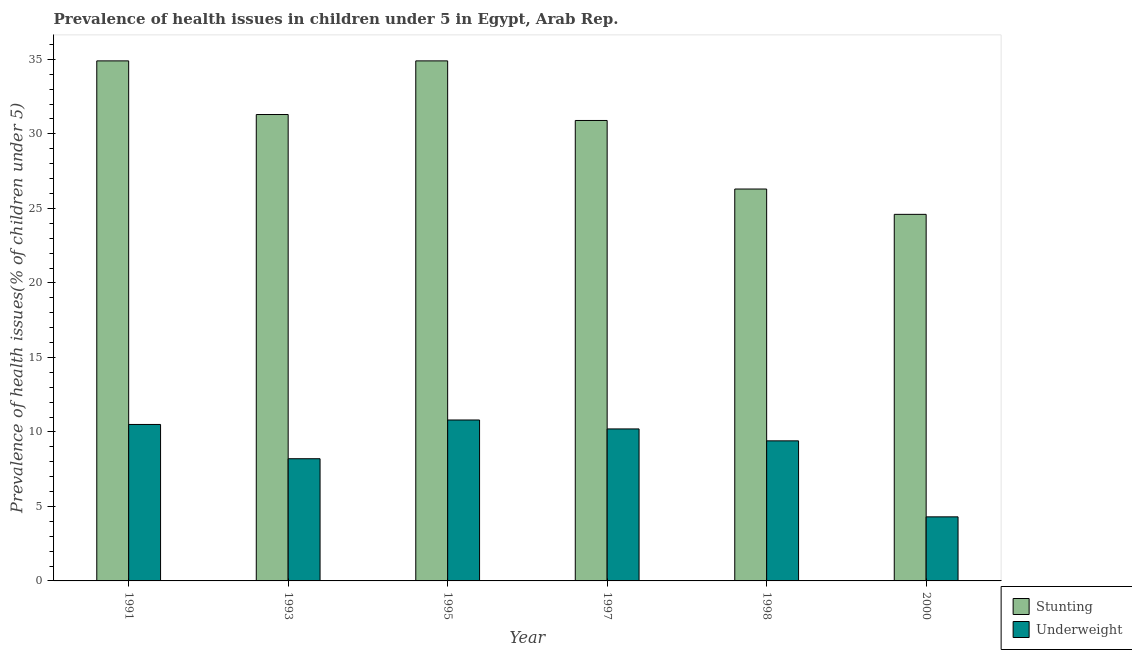How many different coloured bars are there?
Your answer should be very brief. 2. Are the number of bars on each tick of the X-axis equal?
Ensure brevity in your answer.  Yes. How many bars are there on the 6th tick from the left?
Your response must be concise. 2. What is the label of the 1st group of bars from the left?
Give a very brief answer. 1991. In how many cases, is the number of bars for a given year not equal to the number of legend labels?
Offer a terse response. 0. What is the percentage of stunted children in 2000?
Keep it short and to the point. 24.6. Across all years, what is the maximum percentage of underweight children?
Offer a very short reply. 10.8. Across all years, what is the minimum percentage of stunted children?
Keep it short and to the point. 24.6. What is the total percentage of stunted children in the graph?
Give a very brief answer. 182.9. What is the difference between the percentage of stunted children in 1993 and that in 2000?
Ensure brevity in your answer.  6.7. What is the difference between the percentage of stunted children in 1991 and the percentage of underweight children in 1993?
Your answer should be very brief. 3.6. What is the average percentage of underweight children per year?
Make the answer very short. 8.9. In the year 1993, what is the difference between the percentage of underweight children and percentage of stunted children?
Offer a terse response. 0. What is the ratio of the percentage of underweight children in 1997 to that in 1998?
Your answer should be compact. 1.09. Is the difference between the percentage of underweight children in 1991 and 1995 greater than the difference between the percentage of stunted children in 1991 and 1995?
Your response must be concise. No. What is the difference between the highest and the second highest percentage of underweight children?
Offer a terse response. 0.3. What is the difference between the highest and the lowest percentage of stunted children?
Provide a succinct answer. 10.3. Is the sum of the percentage of stunted children in 1995 and 1998 greater than the maximum percentage of underweight children across all years?
Your answer should be very brief. Yes. What does the 1st bar from the left in 1998 represents?
Make the answer very short. Stunting. What does the 2nd bar from the right in 1997 represents?
Provide a succinct answer. Stunting. How many bars are there?
Your answer should be compact. 12. How many years are there in the graph?
Provide a short and direct response. 6. How many legend labels are there?
Give a very brief answer. 2. How are the legend labels stacked?
Offer a terse response. Vertical. What is the title of the graph?
Your answer should be very brief. Prevalence of health issues in children under 5 in Egypt, Arab Rep. What is the label or title of the Y-axis?
Give a very brief answer. Prevalence of health issues(% of children under 5). What is the Prevalence of health issues(% of children under 5) of Stunting in 1991?
Offer a terse response. 34.9. What is the Prevalence of health issues(% of children under 5) of Underweight in 1991?
Keep it short and to the point. 10.5. What is the Prevalence of health issues(% of children under 5) of Stunting in 1993?
Give a very brief answer. 31.3. What is the Prevalence of health issues(% of children under 5) in Underweight in 1993?
Your answer should be compact. 8.2. What is the Prevalence of health issues(% of children under 5) of Stunting in 1995?
Provide a short and direct response. 34.9. What is the Prevalence of health issues(% of children under 5) in Underweight in 1995?
Offer a terse response. 10.8. What is the Prevalence of health issues(% of children under 5) in Stunting in 1997?
Provide a succinct answer. 30.9. What is the Prevalence of health issues(% of children under 5) of Underweight in 1997?
Keep it short and to the point. 10.2. What is the Prevalence of health issues(% of children under 5) of Stunting in 1998?
Provide a short and direct response. 26.3. What is the Prevalence of health issues(% of children under 5) of Underweight in 1998?
Your answer should be very brief. 9.4. What is the Prevalence of health issues(% of children under 5) of Stunting in 2000?
Provide a succinct answer. 24.6. What is the Prevalence of health issues(% of children under 5) of Underweight in 2000?
Your answer should be compact. 4.3. Across all years, what is the maximum Prevalence of health issues(% of children under 5) of Stunting?
Make the answer very short. 34.9. Across all years, what is the maximum Prevalence of health issues(% of children under 5) in Underweight?
Make the answer very short. 10.8. Across all years, what is the minimum Prevalence of health issues(% of children under 5) in Stunting?
Offer a very short reply. 24.6. Across all years, what is the minimum Prevalence of health issues(% of children under 5) in Underweight?
Make the answer very short. 4.3. What is the total Prevalence of health issues(% of children under 5) in Stunting in the graph?
Provide a short and direct response. 182.9. What is the total Prevalence of health issues(% of children under 5) of Underweight in the graph?
Ensure brevity in your answer.  53.4. What is the difference between the Prevalence of health issues(% of children under 5) in Underweight in 1991 and that in 1993?
Make the answer very short. 2.3. What is the difference between the Prevalence of health issues(% of children under 5) in Underweight in 1991 and that in 1995?
Offer a terse response. -0.3. What is the difference between the Prevalence of health issues(% of children under 5) of Stunting in 1991 and that in 1997?
Make the answer very short. 4. What is the difference between the Prevalence of health issues(% of children under 5) of Underweight in 1991 and that in 1997?
Offer a terse response. 0.3. What is the difference between the Prevalence of health issues(% of children under 5) in Stunting in 1991 and that in 1998?
Provide a short and direct response. 8.6. What is the difference between the Prevalence of health issues(% of children under 5) of Underweight in 1991 and that in 1998?
Your response must be concise. 1.1. What is the difference between the Prevalence of health issues(% of children under 5) of Stunting in 1991 and that in 2000?
Offer a very short reply. 10.3. What is the difference between the Prevalence of health issues(% of children under 5) in Underweight in 1991 and that in 2000?
Ensure brevity in your answer.  6.2. What is the difference between the Prevalence of health issues(% of children under 5) in Stunting in 1993 and that in 1995?
Provide a succinct answer. -3.6. What is the difference between the Prevalence of health issues(% of children under 5) in Underweight in 1993 and that in 1998?
Your answer should be very brief. -1.2. What is the difference between the Prevalence of health issues(% of children under 5) in Stunting in 1993 and that in 2000?
Offer a terse response. 6.7. What is the difference between the Prevalence of health issues(% of children under 5) in Stunting in 1995 and that in 1997?
Keep it short and to the point. 4. What is the difference between the Prevalence of health issues(% of children under 5) of Stunting in 1997 and that in 1998?
Provide a succinct answer. 4.6. What is the difference between the Prevalence of health issues(% of children under 5) of Underweight in 1997 and that in 1998?
Keep it short and to the point. 0.8. What is the difference between the Prevalence of health issues(% of children under 5) in Stunting in 1997 and that in 2000?
Your answer should be compact. 6.3. What is the difference between the Prevalence of health issues(% of children under 5) of Underweight in 1997 and that in 2000?
Keep it short and to the point. 5.9. What is the difference between the Prevalence of health issues(% of children under 5) in Stunting in 1998 and that in 2000?
Your answer should be very brief. 1.7. What is the difference between the Prevalence of health issues(% of children under 5) of Stunting in 1991 and the Prevalence of health issues(% of children under 5) of Underweight in 1993?
Provide a succinct answer. 26.7. What is the difference between the Prevalence of health issues(% of children under 5) in Stunting in 1991 and the Prevalence of health issues(% of children under 5) in Underweight in 1995?
Your answer should be compact. 24.1. What is the difference between the Prevalence of health issues(% of children under 5) of Stunting in 1991 and the Prevalence of health issues(% of children under 5) of Underweight in 1997?
Your answer should be very brief. 24.7. What is the difference between the Prevalence of health issues(% of children under 5) in Stunting in 1991 and the Prevalence of health issues(% of children under 5) in Underweight in 1998?
Ensure brevity in your answer.  25.5. What is the difference between the Prevalence of health issues(% of children under 5) in Stunting in 1991 and the Prevalence of health issues(% of children under 5) in Underweight in 2000?
Your answer should be very brief. 30.6. What is the difference between the Prevalence of health issues(% of children under 5) in Stunting in 1993 and the Prevalence of health issues(% of children under 5) in Underweight in 1997?
Offer a very short reply. 21.1. What is the difference between the Prevalence of health issues(% of children under 5) of Stunting in 1993 and the Prevalence of health issues(% of children under 5) of Underweight in 1998?
Your response must be concise. 21.9. What is the difference between the Prevalence of health issues(% of children under 5) of Stunting in 1995 and the Prevalence of health issues(% of children under 5) of Underweight in 1997?
Give a very brief answer. 24.7. What is the difference between the Prevalence of health issues(% of children under 5) of Stunting in 1995 and the Prevalence of health issues(% of children under 5) of Underweight in 1998?
Your answer should be compact. 25.5. What is the difference between the Prevalence of health issues(% of children under 5) of Stunting in 1995 and the Prevalence of health issues(% of children under 5) of Underweight in 2000?
Your response must be concise. 30.6. What is the difference between the Prevalence of health issues(% of children under 5) of Stunting in 1997 and the Prevalence of health issues(% of children under 5) of Underweight in 2000?
Offer a very short reply. 26.6. What is the average Prevalence of health issues(% of children under 5) of Stunting per year?
Your response must be concise. 30.48. What is the average Prevalence of health issues(% of children under 5) of Underweight per year?
Ensure brevity in your answer.  8.9. In the year 1991, what is the difference between the Prevalence of health issues(% of children under 5) in Stunting and Prevalence of health issues(% of children under 5) in Underweight?
Offer a very short reply. 24.4. In the year 1993, what is the difference between the Prevalence of health issues(% of children under 5) in Stunting and Prevalence of health issues(% of children under 5) in Underweight?
Your response must be concise. 23.1. In the year 1995, what is the difference between the Prevalence of health issues(% of children under 5) of Stunting and Prevalence of health issues(% of children under 5) of Underweight?
Provide a succinct answer. 24.1. In the year 1997, what is the difference between the Prevalence of health issues(% of children under 5) in Stunting and Prevalence of health issues(% of children under 5) in Underweight?
Your response must be concise. 20.7. In the year 1998, what is the difference between the Prevalence of health issues(% of children under 5) of Stunting and Prevalence of health issues(% of children under 5) of Underweight?
Ensure brevity in your answer.  16.9. In the year 2000, what is the difference between the Prevalence of health issues(% of children under 5) in Stunting and Prevalence of health issues(% of children under 5) in Underweight?
Ensure brevity in your answer.  20.3. What is the ratio of the Prevalence of health issues(% of children under 5) of Stunting in 1991 to that in 1993?
Make the answer very short. 1.11. What is the ratio of the Prevalence of health issues(% of children under 5) in Underweight in 1991 to that in 1993?
Keep it short and to the point. 1.28. What is the ratio of the Prevalence of health issues(% of children under 5) in Underweight in 1991 to that in 1995?
Provide a succinct answer. 0.97. What is the ratio of the Prevalence of health issues(% of children under 5) in Stunting in 1991 to that in 1997?
Your response must be concise. 1.13. What is the ratio of the Prevalence of health issues(% of children under 5) of Underweight in 1991 to that in 1997?
Your response must be concise. 1.03. What is the ratio of the Prevalence of health issues(% of children under 5) of Stunting in 1991 to that in 1998?
Offer a very short reply. 1.33. What is the ratio of the Prevalence of health issues(% of children under 5) in Underweight in 1991 to that in 1998?
Offer a very short reply. 1.12. What is the ratio of the Prevalence of health issues(% of children under 5) of Stunting in 1991 to that in 2000?
Give a very brief answer. 1.42. What is the ratio of the Prevalence of health issues(% of children under 5) in Underweight in 1991 to that in 2000?
Your answer should be compact. 2.44. What is the ratio of the Prevalence of health issues(% of children under 5) of Stunting in 1993 to that in 1995?
Keep it short and to the point. 0.9. What is the ratio of the Prevalence of health issues(% of children under 5) of Underweight in 1993 to that in 1995?
Provide a short and direct response. 0.76. What is the ratio of the Prevalence of health issues(% of children under 5) of Stunting in 1993 to that in 1997?
Make the answer very short. 1.01. What is the ratio of the Prevalence of health issues(% of children under 5) in Underweight in 1993 to that in 1997?
Keep it short and to the point. 0.8. What is the ratio of the Prevalence of health issues(% of children under 5) in Stunting in 1993 to that in 1998?
Provide a short and direct response. 1.19. What is the ratio of the Prevalence of health issues(% of children under 5) in Underweight in 1993 to that in 1998?
Give a very brief answer. 0.87. What is the ratio of the Prevalence of health issues(% of children under 5) of Stunting in 1993 to that in 2000?
Offer a very short reply. 1.27. What is the ratio of the Prevalence of health issues(% of children under 5) in Underweight in 1993 to that in 2000?
Offer a terse response. 1.91. What is the ratio of the Prevalence of health issues(% of children under 5) of Stunting in 1995 to that in 1997?
Provide a succinct answer. 1.13. What is the ratio of the Prevalence of health issues(% of children under 5) of Underweight in 1995 to that in 1997?
Offer a very short reply. 1.06. What is the ratio of the Prevalence of health issues(% of children under 5) of Stunting in 1995 to that in 1998?
Give a very brief answer. 1.33. What is the ratio of the Prevalence of health issues(% of children under 5) in Underweight in 1995 to that in 1998?
Your answer should be very brief. 1.15. What is the ratio of the Prevalence of health issues(% of children under 5) in Stunting in 1995 to that in 2000?
Your answer should be compact. 1.42. What is the ratio of the Prevalence of health issues(% of children under 5) of Underweight in 1995 to that in 2000?
Keep it short and to the point. 2.51. What is the ratio of the Prevalence of health issues(% of children under 5) of Stunting in 1997 to that in 1998?
Provide a succinct answer. 1.17. What is the ratio of the Prevalence of health issues(% of children under 5) in Underweight in 1997 to that in 1998?
Ensure brevity in your answer.  1.09. What is the ratio of the Prevalence of health issues(% of children under 5) of Stunting in 1997 to that in 2000?
Provide a short and direct response. 1.26. What is the ratio of the Prevalence of health issues(% of children under 5) of Underweight in 1997 to that in 2000?
Your response must be concise. 2.37. What is the ratio of the Prevalence of health issues(% of children under 5) in Stunting in 1998 to that in 2000?
Your response must be concise. 1.07. What is the ratio of the Prevalence of health issues(% of children under 5) in Underweight in 1998 to that in 2000?
Give a very brief answer. 2.19. What is the difference between the highest and the second highest Prevalence of health issues(% of children under 5) of Stunting?
Give a very brief answer. 0. What is the difference between the highest and the second highest Prevalence of health issues(% of children under 5) of Underweight?
Make the answer very short. 0.3. What is the difference between the highest and the lowest Prevalence of health issues(% of children under 5) in Stunting?
Provide a succinct answer. 10.3. 